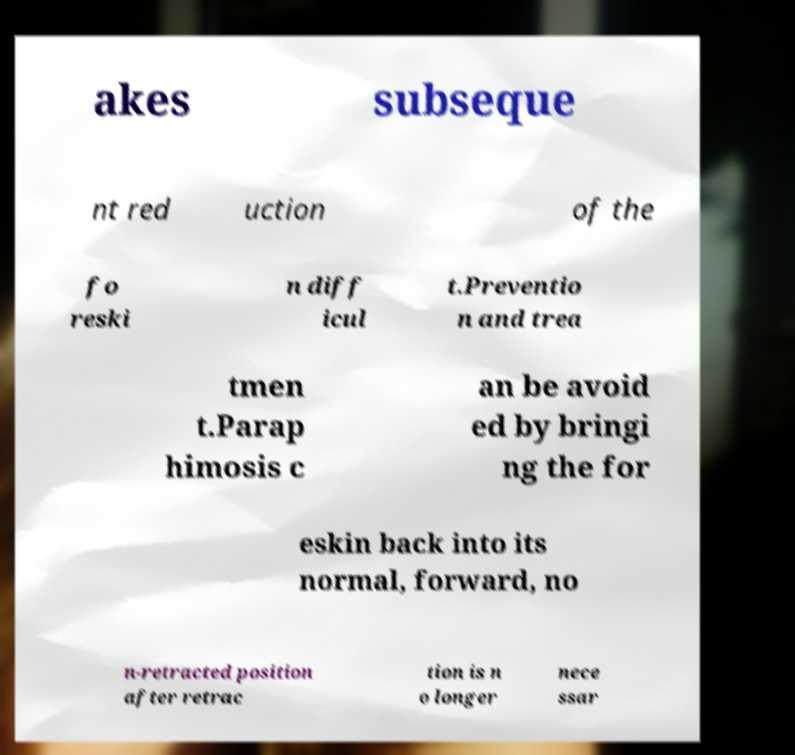I need the written content from this picture converted into text. Can you do that? akes subseque nt red uction of the fo reski n diff icul t.Preventio n and trea tmen t.Parap himosis c an be avoid ed by bringi ng the for eskin back into its normal, forward, no n-retracted position after retrac tion is n o longer nece ssar 